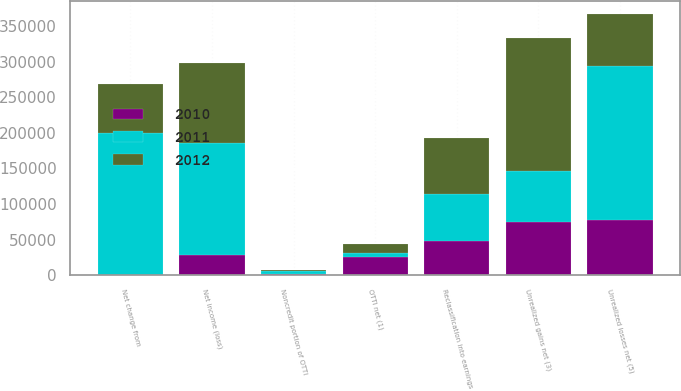Convert chart to OTSL. <chart><loc_0><loc_0><loc_500><loc_500><stacked_bar_chart><ecel><fcel>Net income (loss)<fcel>OTTI net (1)<fcel>Noncredit portion of OTTI<fcel>Unrealized gains net (3)<fcel>Reclassification into earnings<fcel>Net change from<fcel>Unrealized losses net (5)<nl><fcel>2012<fcel>112583<fcel>12285<fcel>1843<fcel>186348<fcel>77731<fcel>68642<fcel>72119<nl><fcel>2011<fcel>156701<fcel>5709<fcel>3589<fcel>72119<fcel>66847<fcel>199643<fcel>216302<nl><fcel>2010<fcel>28472<fcel>25662<fcel>2320<fcel>74826<fcel>47774<fcel>240<fcel>77724<nl></chart> 